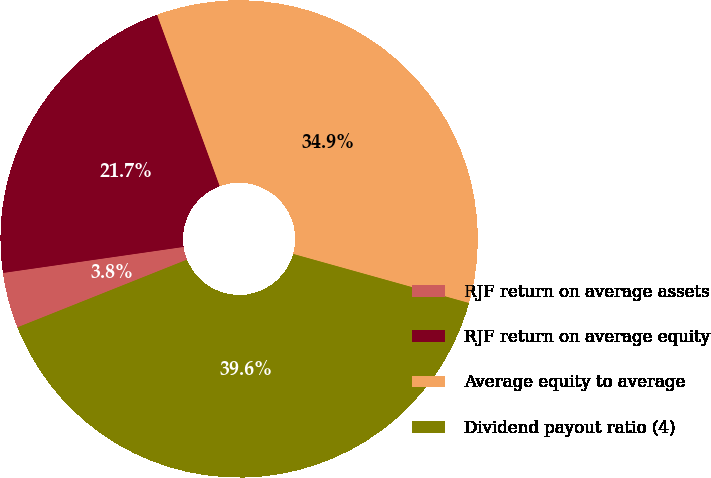<chart> <loc_0><loc_0><loc_500><loc_500><pie_chart><fcel>RJF return on average assets<fcel>RJF return on average equity<fcel>Average equity to average<fcel>Dividend payout ratio (4)<nl><fcel>3.77%<fcel>21.7%<fcel>34.91%<fcel>39.62%<nl></chart> 